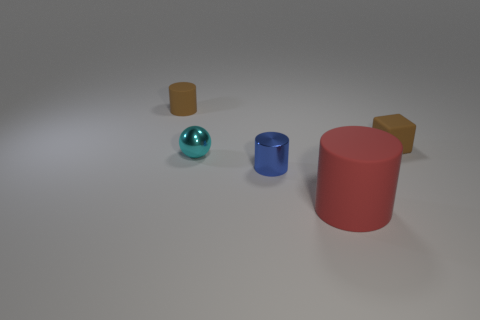Add 2 large red rubber cylinders. How many objects exist? 7 Subtract all spheres. How many objects are left? 4 Add 4 big brown cylinders. How many big brown cylinders exist? 4 Subtract 0 gray cylinders. How many objects are left? 5 Subtract all big cyan metal cubes. Subtract all cyan balls. How many objects are left? 4 Add 5 tiny blue things. How many tiny blue things are left? 6 